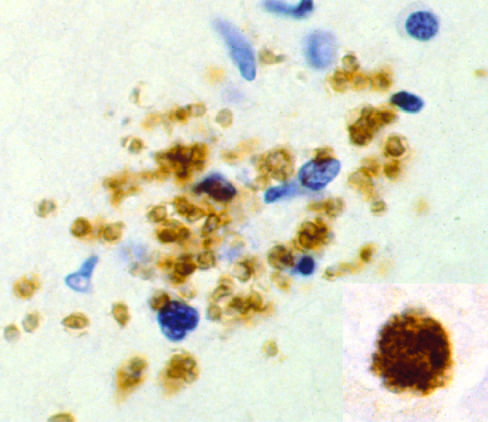re free tachyzoites demonstrated by immunohistochemical staining?
Answer the question using a single word or phrase. Yes 